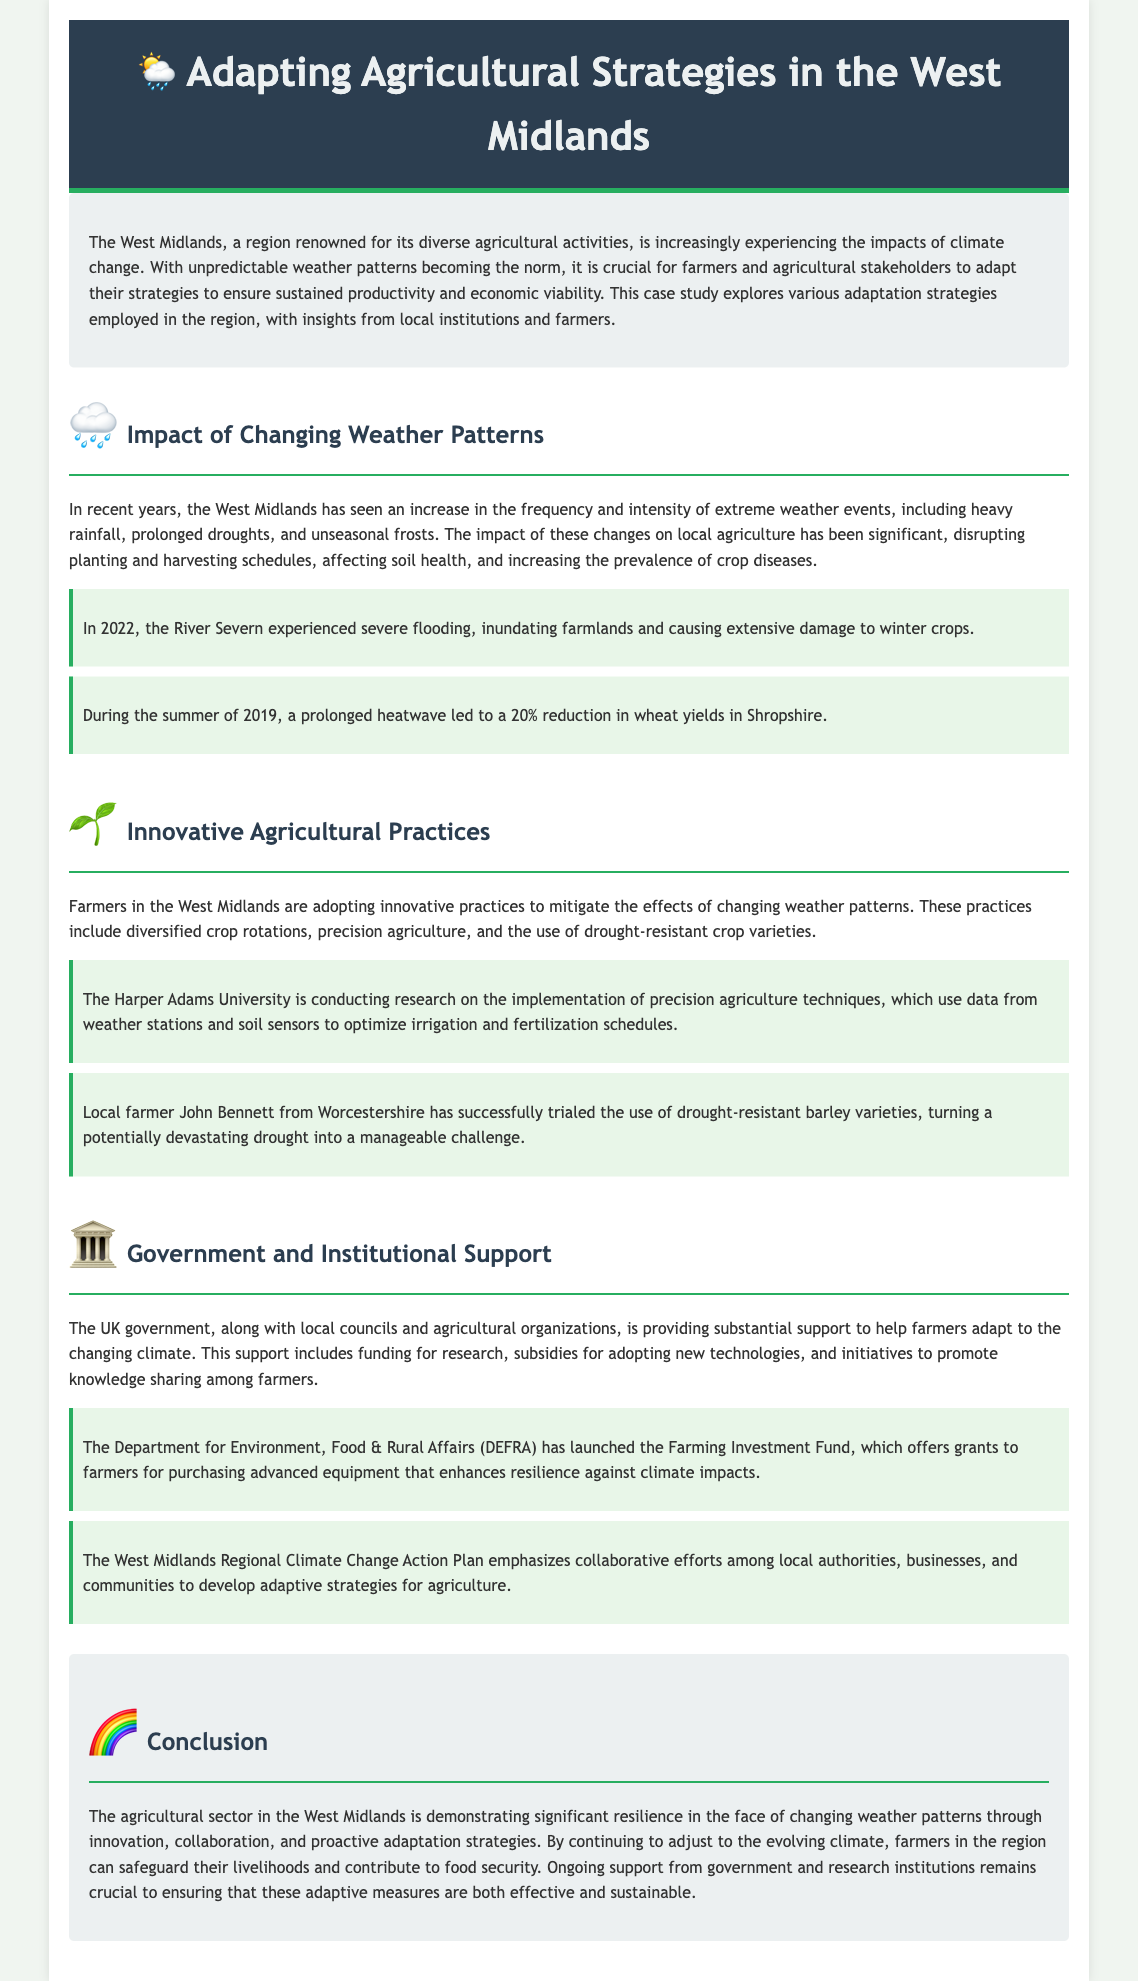What is the main focus of the case study? The main focus of the case study is on adapting agricultural strategies in response to changing weather patterns in the West Midlands.
Answer: Adapting agricultural strategies What significant weather event occurred in 2022? The document mentions that in 2022, the River Severn experienced severe flooding that affected agriculture.
Answer: Severe flooding Which crop had a yield reduction in the summer of 2019? A prolonged heatwave in the summer of 2019 led to a 20% reduction in wheat yields.
Answer: Wheat What innovative practice is being researched at Harper Adams University? The research at Harper Adams University focuses on the implementation of precision agriculture techniques.
Answer: Precision agriculture What government initiative offers grants for advanced agricultural equipment? The initiative launched is called the Farming Investment Fund, which offers grants to farmers.
Answer: Farming Investment Fund Who is a local farmer mentioned in the case study? The case study mentions local farmer John Bennett from Worcestershire.
Answer: John Bennett What does DEFRA stand for? DEFRA stands for the Department for Environment, Food & Rural Affairs.
Answer: Department for Environment, Food & Rural Affairs What was the impact of prolonged drought on local agriculture? Prolonged droughts have disturbed planting and harvesting schedules and affected soil health.
Answer: Disturbed planting and harvesting schedules What is the overall conclusion regarding the agricultural sector in the West Midlands? The conclusion emphasizes that the agricultural sector is demonstrating significant resilience through innovation and collaborative efforts.
Answer: Significant resilience 